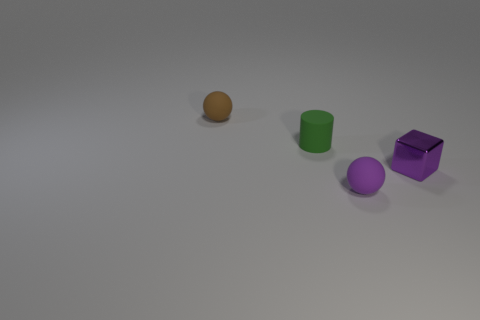Add 2 large red cylinders. How many objects exist? 6 Subtract 1 balls. How many balls are left? 1 Subtract all brown balls. How many balls are left? 1 Subtract all purple cylinders. Subtract all red balls. How many cylinders are left? 1 Subtract all cyan blocks. How many brown balls are left? 1 Subtract all yellow rubber objects. Subtract all small shiny objects. How many objects are left? 3 Add 2 metal blocks. How many metal blocks are left? 3 Add 1 purple rubber spheres. How many purple rubber spheres exist? 2 Subtract 0 blue cubes. How many objects are left? 4 Subtract all blocks. How many objects are left? 3 